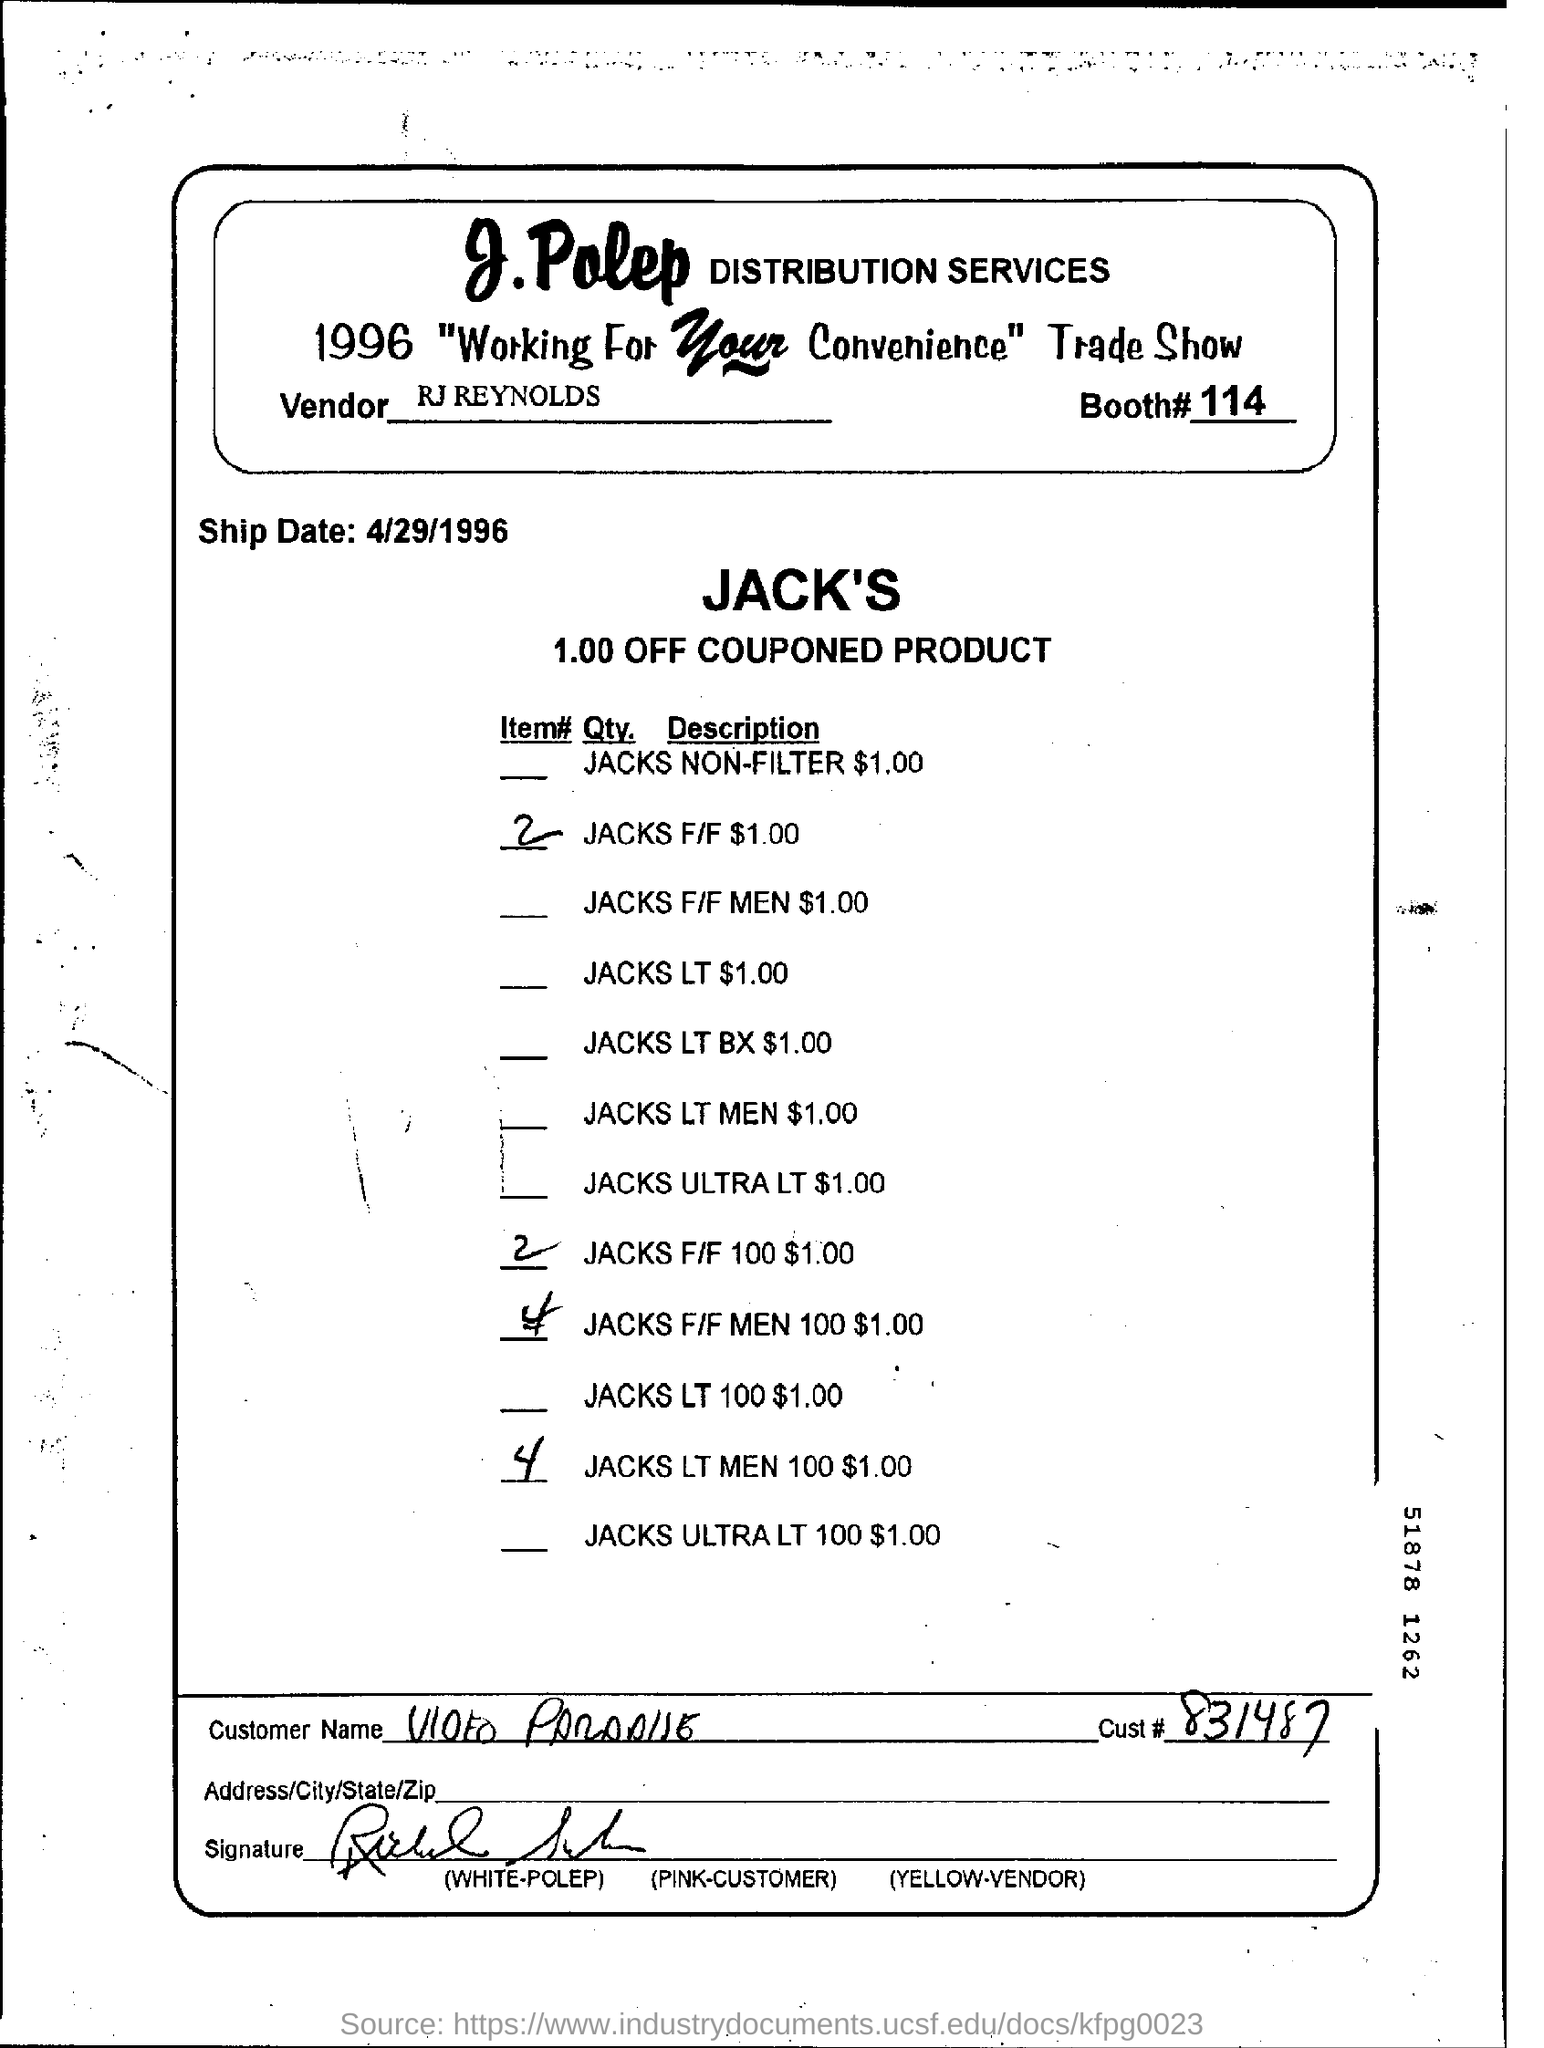Indicate a few pertinent items in this graphic. The Booth number mentioned in the document is 114. The vendor mentioned in the document is RJ Reynolds. The Ship Date mentioned in this document is 4/29/1996. 